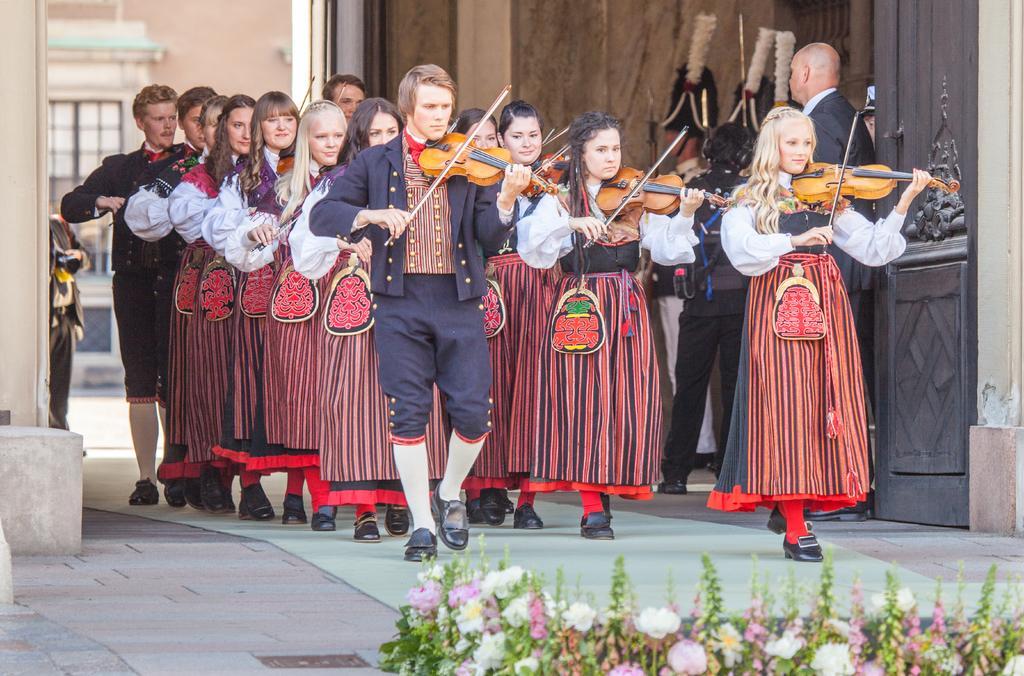Please provide a concise description of this image. In this picture we can see a group of people standing on the floor, and playing violin, and here is the building, and here a person is standing, and here are the flowers. 